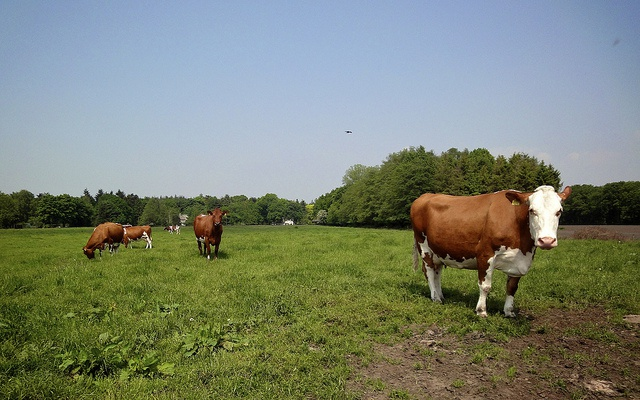Describe the objects in this image and their specific colors. I can see cow in gray, maroon, black, brown, and tan tones, cow in gray, black, maroon, and brown tones, cow in gray, black, brown, maroon, and olive tones, cow in gray, maroon, brown, olive, and black tones, and cow in gray, olive, and black tones in this image. 